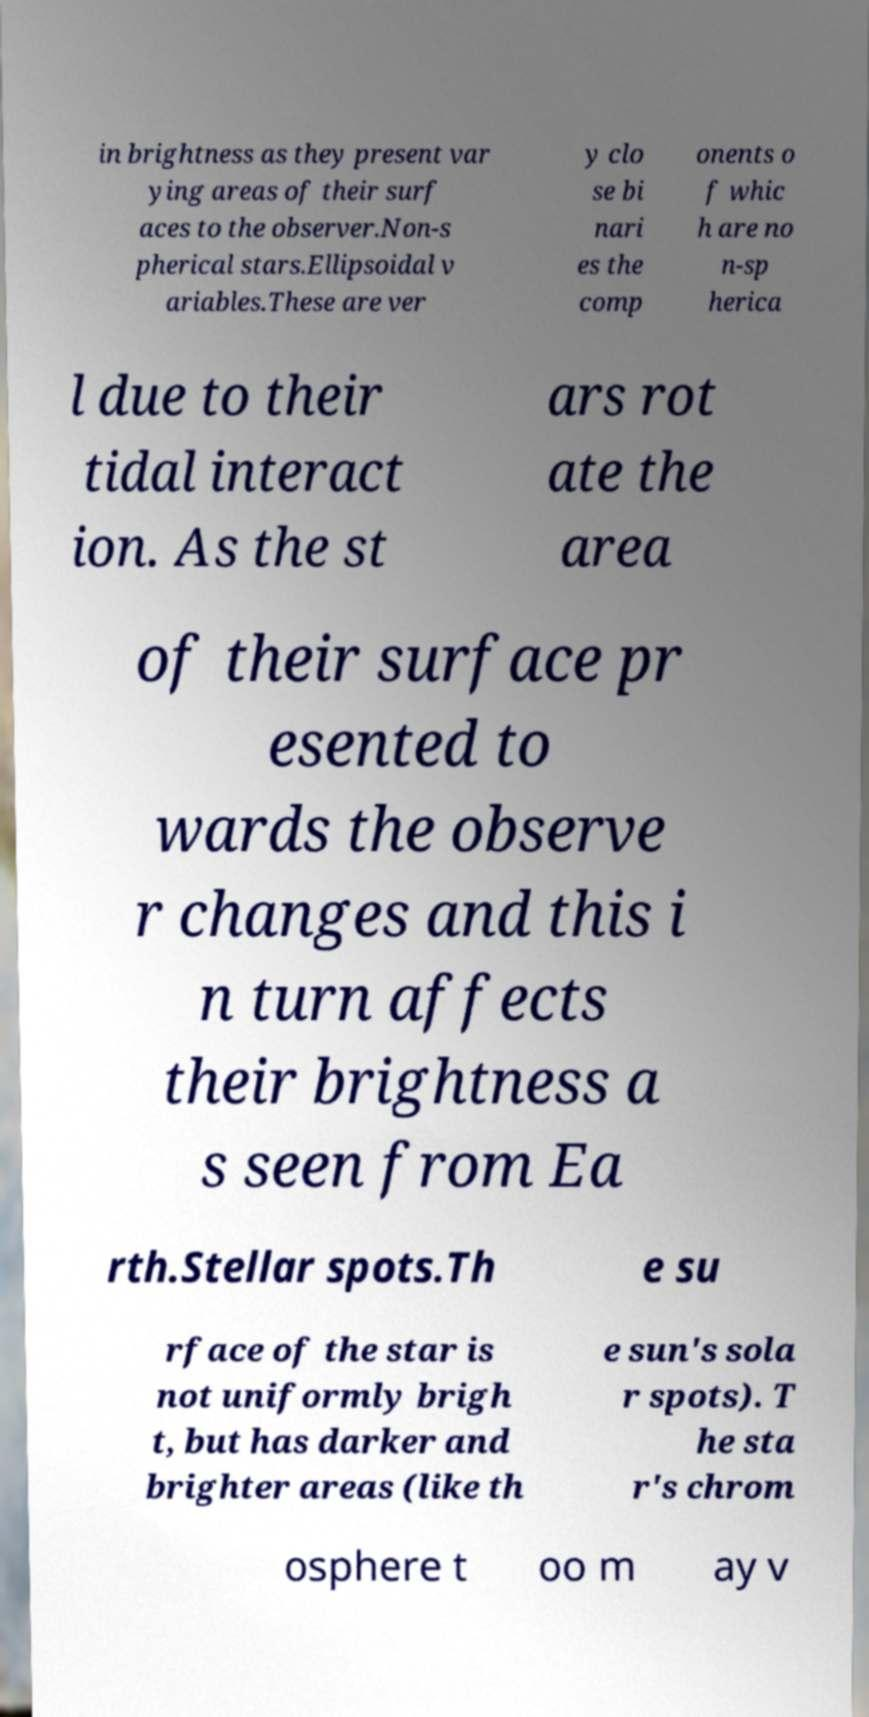Can you accurately transcribe the text from the provided image for me? in brightness as they present var ying areas of their surf aces to the observer.Non-s pherical stars.Ellipsoidal v ariables.These are ver y clo se bi nari es the comp onents o f whic h are no n-sp herica l due to their tidal interact ion. As the st ars rot ate the area of their surface pr esented to wards the observe r changes and this i n turn affects their brightness a s seen from Ea rth.Stellar spots.Th e su rface of the star is not uniformly brigh t, but has darker and brighter areas (like th e sun's sola r spots). T he sta r's chrom osphere t oo m ay v 